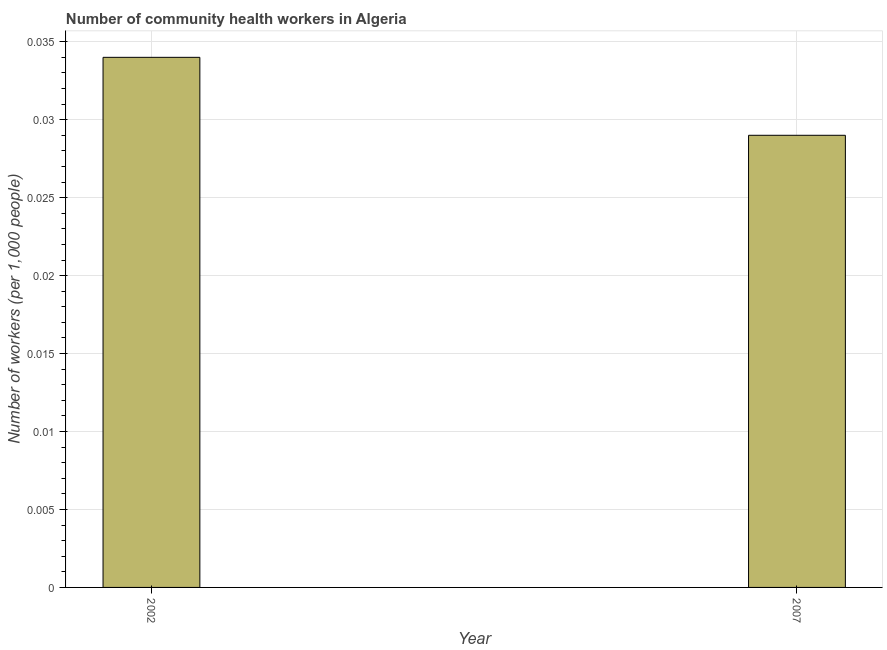Does the graph contain any zero values?
Provide a succinct answer. No. Does the graph contain grids?
Your response must be concise. Yes. What is the title of the graph?
Make the answer very short. Number of community health workers in Algeria. What is the label or title of the Y-axis?
Provide a short and direct response. Number of workers (per 1,0 people). What is the number of community health workers in 2007?
Your response must be concise. 0.03. Across all years, what is the maximum number of community health workers?
Your response must be concise. 0.03. Across all years, what is the minimum number of community health workers?
Provide a succinct answer. 0.03. What is the sum of the number of community health workers?
Make the answer very short. 0.06. What is the difference between the number of community health workers in 2002 and 2007?
Keep it short and to the point. 0.01. What is the average number of community health workers per year?
Offer a terse response. 0.03. What is the median number of community health workers?
Your answer should be very brief. 0.03. In how many years, is the number of community health workers greater than 0.004 ?
Provide a succinct answer. 2. What is the ratio of the number of community health workers in 2002 to that in 2007?
Keep it short and to the point. 1.17. In how many years, is the number of community health workers greater than the average number of community health workers taken over all years?
Your answer should be very brief. 1. How many bars are there?
Make the answer very short. 2. Are all the bars in the graph horizontal?
Offer a very short reply. No. What is the difference between two consecutive major ticks on the Y-axis?
Your answer should be compact. 0.01. Are the values on the major ticks of Y-axis written in scientific E-notation?
Ensure brevity in your answer.  No. What is the Number of workers (per 1,000 people) of 2002?
Your answer should be very brief. 0.03. What is the Number of workers (per 1,000 people) of 2007?
Your response must be concise. 0.03. What is the difference between the Number of workers (per 1,000 people) in 2002 and 2007?
Your answer should be compact. 0.01. What is the ratio of the Number of workers (per 1,000 people) in 2002 to that in 2007?
Provide a short and direct response. 1.17. 